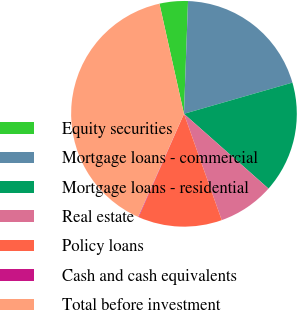Convert chart. <chart><loc_0><loc_0><loc_500><loc_500><pie_chart><fcel>Equity securities<fcel>Mortgage loans - commercial<fcel>Mortgage loans - residential<fcel>Real estate<fcel>Policy loans<fcel>Cash and cash equivalents<fcel>Total before investment<nl><fcel>4.06%<fcel>19.97%<fcel>15.99%<fcel>8.04%<fcel>12.01%<fcel>0.08%<fcel>39.86%<nl></chart> 